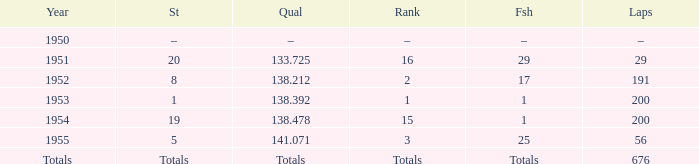How many laps was qualifier of 138.212? 191.0. 